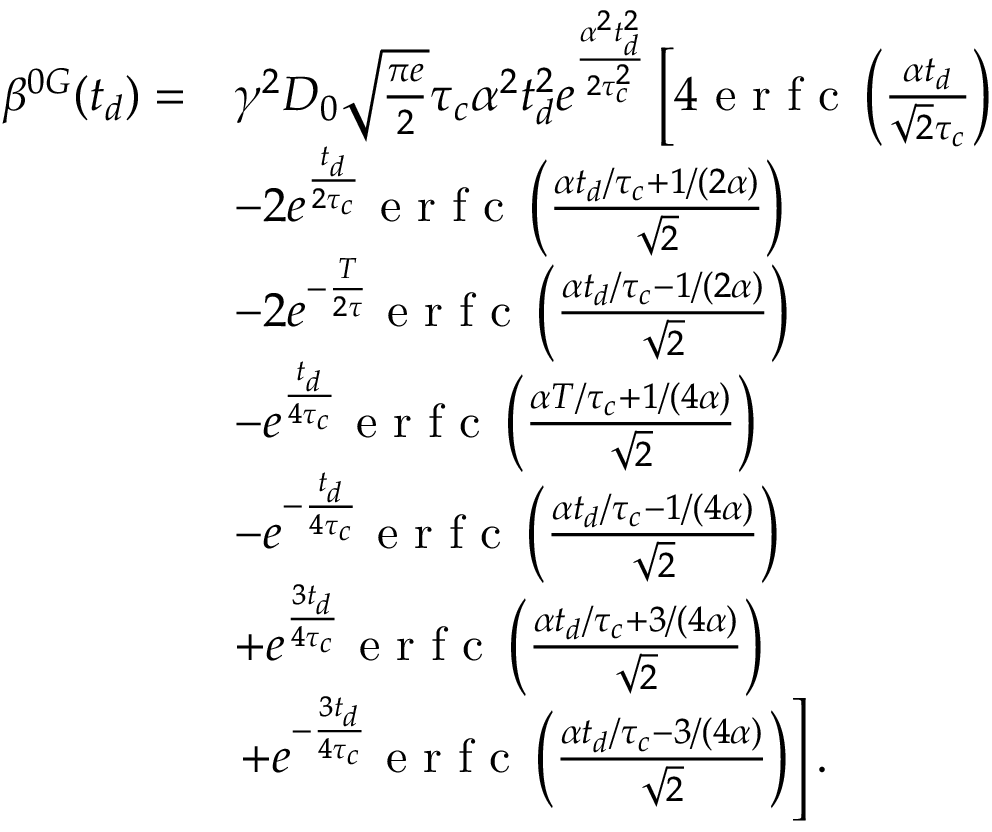Convert formula to latex. <formula><loc_0><loc_0><loc_500><loc_500>\begin{array} { r l } { \beta ^ { 0 G } ( t _ { d } ) = } & { \gamma ^ { 2 } D _ { 0 } \sqrt { \frac { \pi e } { 2 } } \tau _ { c } \alpha ^ { 2 } t _ { d } ^ { 2 } e ^ { \frac { \alpha ^ { 2 } t _ { d } ^ { 2 } } { 2 \tau _ { c } ^ { 2 } } } \left [ 4 e r f c \left ( \frac { \alpha t _ { d } } { \sqrt { 2 } \tau _ { c } } \right ) } \\ & { - 2 e ^ { \frac { t _ { d } } { 2 \tau _ { c } } } e r f c \left ( \frac { \alpha t _ { d } / \tau _ { c } + 1 / ( 2 \alpha ) } { \sqrt { 2 } } \right ) } \\ & { - 2 e ^ { - \frac { T } { 2 \tau } } e r f c \left ( \frac { \alpha t _ { d } / \tau _ { c } - 1 / ( 2 \alpha ) } { \sqrt { 2 } } \right ) } \\ & { - e ^ { \frac { t _ { d } } { 4 \tau _ { c } } } e r f c \left ( \frac { \alpha T / \tau _ { c } + 1 / ( 4 \alpha ) } { \sqrt { 2 } } \right ) } \\ & { - e ^ { - \frac { t _ { d } } { 4 \tau _ { c } } } e r f c \left ( \frac { \alpha t _ { d } / \tau _ { c } - 1 / ( 4 \alpha ) } { \sqrt { 2 } } \right ) } \\ & { + e ^ { \frac { 3 t _ { d } } { 4 \tau _ { c } } } e r f c \left ( \frac { \alpha t _ { d } / \tau _ { c } + 3 / ( 4 \alpha ) } { \sqrt { 2 } } \right ) } \\ & { + e ^ { - \frac { 3 t _ { d } } { 4 \tau _ { c } } } e r f c \left ( \frac { \alpha t _ { d } / \tau _ { c } - 3 / ( 4 \alpha ) } { \sqrt { 2 } } \right ) \right ] . } \end{array}</formula> 